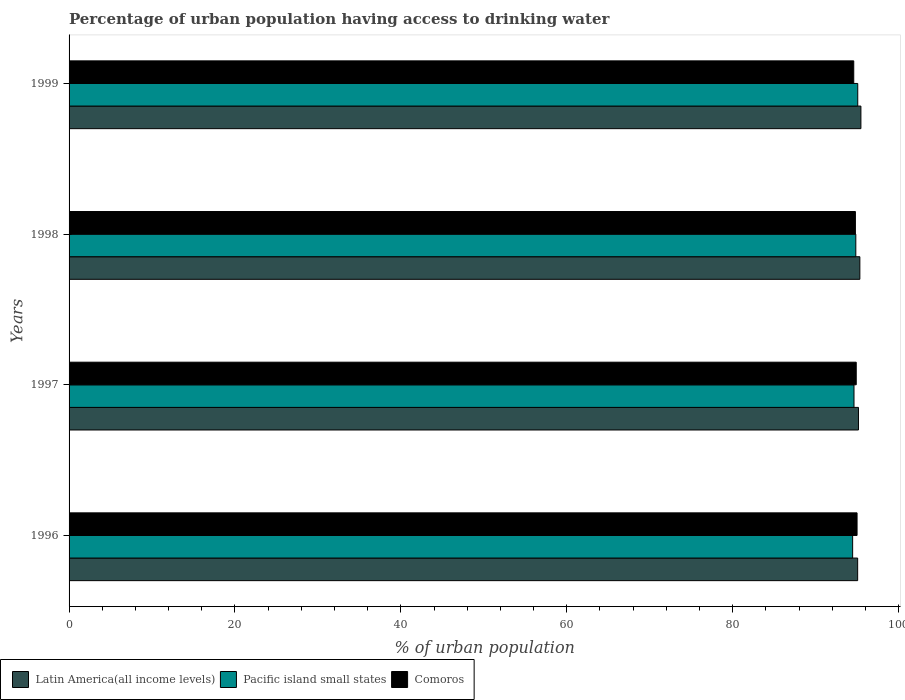Are the number of bars on each tick of the Y-axis equal?
Provide a succinct answer. Yes. How many bars are there on the 2nd tick from the top?
Offer a very short reply. 3. How many bars are there on the 2nd tick from the bottom?
Offer a terse response. 3. What is the percentage of urban population having access to drinking water in Pacific island small states in 1998?
Your answer should be very brief. 94.85. Across all years, what is the maximum percentage of urban population having access to drinking water in Comoros?
Your answer should be compact. 95. Across all years, what is the minimum percentage of urban population having access to drinking water in Comoros?
Your answer should be compact. 94.6. In which year was the percentage of urban population having access to drinking water in Comoros maximum?
Ensure brevity in your answer.  1996. In which year was the percentage of urban population having access to drinking water in Latin America(all income levels) minimum?
Give a very brief answer. 1996. What is the total percentage of urban population having access to drinking water in Latin America(all income levels) in the graph?
Your response must be concise. 381.04. What is the difference between the percentage of urban population having access to drinking water in Latin America(all income levels) in 1997 and that in 1998?
Provide a short and direct response. -0.17. What is the difference between the percentage of urban population having access to drinking water in Latin America(all income levels) in 1998 and the percentage of urban population having access to drinking water in Comoros in 1997?
Make the answer very short. 0.44. What is the average percentage of urban population having access to drinking water in Comoros per year?
Ensure brevity in your answer.  94.82. In the year 1996, what is the difference between the percentage of urban population having access to drinking water in Pacific island small states and percentage of urban population having access to drinking water in Comoros?
Provide a short and direct response. -0.53. What is the ratio of the percentage of urban population having access to drinking water in Pacific island small states in 1998 to that in 1999?
Offer a very short reply. 1. What is the difference between the highest and the second highest percentage of urban population having access to drinking water in Pacific island small states?
Offer a terse response. 0.23. What is the difference between the highest and the lowest percentage of urban population having access to drinking water in Pacific island small states?
Make the answer very short. 0.62. Is the sum of the percentage of urban population having access to drinking water in Latin America(all income levels) in 1996 and 1998 greater than the maximum percentage of urban population having access to drinking water in Pacific island small states across all years?
Ensure brevity in your answer.  Yes. What does the 3rd bar from the top in 1998 represents?
Your answer should be compact. Latin America(all income levels). What does the 2nd bar from the bottom in 1999 represents?
Keep it short and to the point. Pacific island small states. How many years are there in the graph?
Keep it short and to the point. 4. Does the graph contain grids?
Make the answer very short. No. How are the legend labels stacked?
Make the answer very short. Horizontal. What is the title of the graph?
Provide a succinct answer. Percentage of urban population having access to drinking water. Does "Maldives" appear as one of the legend labels in the graph?
Your answer should be very brief. No. What is the label or title of the X-axis?
Provide a succinct answer. % of urban population. What is the % of urban population in Latin America(all income levels) in 1996?
Offer a very short reply. 95.07. What is the % of urban population in Pacific island small states in 1996?
Your answer should be very brief. 94.47. What is the % of urban population of Comoros in 1996?
Your answer should be very brief. 95. What is the % of urban population in Latin America(all income levels) in 1997?
Your answer should be very brief. 95.17. What is the % of urban population of Pacific island small states in 1997?
Offer a terse response. 94.63. What is the % of urban population of Comoros in 1997?
Give a very brief answer. 94.9. What is the % of urban population of Latin America(all income levels) in 1998?
Offer a terse response. 95.34. What is the % of urban population in Pacific island small states in 1998?
Ensure brevity in your answer.  94.85. What is the % of urban population of Comoros in 1998?
Keep it short and to the point. 94.8. What is the % of urban population of Latin America(all income levels) in 1999?
Your answer should be compact. 95.46. What is the % of urban population in Pacific island small states in 1999?
Make the answer very short. 95.08. What is the % of urban population of Comoros in 1999?
Your answer should be very brief. 94.6. Across all years, what is the maximum % of urban population in Latin America(all income levels)?
Provide a short and direct response. 95.46. Across all years, what is the maximum % of urban population in Pacific island small states?
Your answer should be compact. 95.08. Across all years, what is the minimum % of urban population in Latin America(all income levels)?
Ensure brevity in your answer.  95.07. Across all years, what is the minimum % of urban population in Pacific island small states?
Give a very brief answer. 94.47. Across all years, what is the minimum % of urban population in Comoros?
Your response must be concise. 94.6. What is the total % of urban population in Latin America(all income levels) in the graph?
Your response must be concise. 381.04. What is the total % of urban population of Pacific island small states in the graph?
Your answer should be compact. 379.03. What is the total % of urban population of Comoros in the graph?
Make the answer very short. 379.3. What is the difference between the % of urban population in Latin America(all income levels) in 1996 and that in 1997?
Make the answer very short. -0.1. What is the difference between the % of urban population in Pacific island small states in 1996 and that in 1997?
Your answer should be compact. -0.16. What is the difference between the % of urban population of Comoros in 1996 and that in 1997?
Keep it short and to the point. 0.1. What is the difference between the % of urban population in Latin America(all income levels) in 1996 and that in 1998?
Your answer should be very brief. -0.27. What is the difference between the % of urban population of Pacific island small states in 1996 and that in 1998?
Your answer should be compact. -0.38. What is the difference between the % of urban population in Latin America(all income levels) in 1996 and that in 1999?
Ensure brevity in your answer.  -0.39. What is the difference between the % of urban population of Pacific island small states in 1996 and that in 1999?
Make the answer very short. -0.62. What is the difference between the % of urban population in Comoros in 1996 and that in 1999?
Make the answer very short. 0.4. What is the difference between the % of urban population of Latin America(all income levels) in 1997 and that in 1998?
Make the answer very short. -0.17. What is the difference between the % of urban population in Pacific island small states in 1997 and that in 1998?
Keep it short and to the point. -0.22. What is the difference between the % of urban population of Latin America(all income levels) in 1997 and that in 1999?
Make the answer very short. -0.29. What is the difference between the % of urban population of Pacific island small states in 1997 and that in 1999?
Provide a succinct answer. -0.45. What is the difference between the % of urban population in Latin America(all income levels) in 1998 and that in 1999?
Give a very brief answer. -0.13. What is the difference between the % of urban population of Pacific island small states in 1998 and that in 1999?
Keep it short and to the point. -0.23. What is the difference between the % of urban population of Comoros in 1998 and that in 1999?
Your response must be concise. 0.2. What is the difference between the % of urban population of Latin America(all income levels) in 1996 and the % of urban population of Pacific island small states in 1997?
Give a very brief answer. 0.44. What is the difference between the % of urban population in Latin America(all income levels) in 1996 and the % of urban population in Comoros in 1997?
Your response must be concise. 0.17. What is the difference between the % of urban population of Pacific island small states in 1996 and the % of urban population of Comoros in 1997?
Give a very brief answer. -0.43. What is the difference between the % of urban population in Latin America(all income levels) in 1996 and the % of urban population in Pacific island small states in 1998?
Provide a succinct answer. 0.22. What is the difference between the % of urban population in Latin America(all income levels) in 1996 and the % of urban population in Comoros in 1998?
Provide a succinct answer. 0.27. What is the difference between the % of urban population of Pacific island small states in 1996 and the % of urban population of Comoros in 1998?
Make the answer very short. -0.33. What is the difference between the % of urban population in Latin America(all income levels) in 1996 and the % of urban population in Pacific island small states in 1999?
Ensure brevity in your answer.  -0.01. What is the difference between the % of urban population in Latin America(all income levels) in 1996 and the % of urban population in Comoros in 1999?
Provide a succinct answer. 0.47. What is the difference between the % of urban population in Pacific island small states in 1996 and the % of urban population in Comoros in 1999?
Give a very brief answer. -0.13. What is the difference between the % of urban population of Latin America(all income levels) in 1997 and the % of urban population of Pacific island small states in 1998?
Give a very brief answer. 0.32. What is the difference between the % of urban population of Latin America(all income levels) in 1997 and the % of urban population of Comoros in 1998?
Offer a terse response. 0.37. What is the difference between the % of urban population of Pacific island small states in 1997 and the % of urban population of Comoros in 1998?
Give a very brief answer. -0.17. What is the difference between the % of urban population in Latin America(all income levels) in 1997 and the % of urban population in Pacific island small states in 1999?
Your answer should be compact. 0.09. What is the difference between the % of urban population in Latin America(all income levels) in 1997 and the % of urban population in Comoros in 1999?
Make the answer very short. 0.57. What is the difference between the % of urban population of Pacific island small states in 1997 and the % of urban population of Comoros in 1999?
Offer a terse response. 0.03. What is the difference between the % of urban population of Latin America(all income levels) in 1998 and the % of urban population of Pacific island small states in 1999?
Keep it short and to the point. 0.25. What is the difference between the % of urban population in Latin America(all income levels) in 1998 and the % of urban population in Comoros in 1999?
Keep it short and to the point. 0.74. What is the difference between the % of urban population in Pacific island small states in 1998 and the % of urban population in Comoros in 1999?
Your response must be concise. 0.25. What is the average % of urban population in Latin America(all income levels) per year?
Give a very brief answer. 95.26. What is the average % of urban population in Pacific island small states per year?
Ensure brevity in your answer.  94.76. What is the average % of urban population in Comoros per year?
Your answer should be very brief. 94.83. In the year 1996, what is the difference between the % of urban population of Latin America(all income levels) and % of urban population of Pacific island small states?
Provide a short and direct response. 0.6. In the year 1996, what is the difference between the % of urban population of Latin America(all income levels) and % of urban population of Comoros?
Keep it short and to the point. 0.07. In the year 1996, what is the difference between the % of urban population of Pacific island small states and % of urban population of Comoros?
Your response must be concise. -0.53. In the year 1997, what is the difference between the % of urban population in Latin America(all income levels) and % of urban population in Pacific island small states?
Provide a short and direct response. 0.54. In the year 1997, what is the difference between the % of urban population of Latin America(all income levels) and % of urban population of Comoros?
Your answer should be compact. 0.27. In the year 1997, what is the difference between the % of urban population of Pacific island small states and % of urban population of Comoros?
Ensure brevity in your answer.  -0.27. In the year 1998, what is the difference between the % of urban population in Latin America(all income levels) and % of urban population in Pacific island small states?
Make the answer very short. 0.49. In the year 1998, what is the difference between the % of urban population of Latin America(all income levels) and % of urban population of Comoros?
Your answer should be compact. 0.54. In the year 1998, what is the difference between the % of urban population in Pacific island small states and % of urban population in Comoros?
Your answer should be compact. 0.05. In the year 1999, what is the difference between the % of urban population in Latin America(all income levels) and % of urban population in Pacific island small states?
Your answer should be compact. 0.38. In the year 1999, what is the difference between the % of urban population in Latin America(all income levels) and % of urban population in Comoros?
Provide a short and direct response. 0.86. In the year 1999, what is the difference between the % of urban population of Pacific island small states and % of urban population of Comoros?
Your response must be concise. 0.48. What is the ratio of the % of urban population of Latin America(all income levels) in 1996 to that in 1997?
Provide a short and direct response. 1. What is the ratio of the % of urban population of Latin America(all income levels) in 1996 to that in 1998?
Your response must be concise. 1. What is the ratio of the % of urban population in Pacific island small states in 1996 to that in 1998?
Offer a very short reply. 1. What is the ratio of the % of urban population of Comoros in 1996 to that in 1998?
Ensure brevity in your answer.  1. What is the ratio of the % of urban population in Pacific island small states in 1996 to that in 1999?
Your answer should be very brief. 0.99. What is the ratio of the % of urban population in Pacific island small states in 1997 to that in 1999?
Ensure brevity in your answer.  1. What is the ratio of the % of urban population of Comoros in 1997 to that in 1999?
Provide a succinct answer. 1. What is the ratio of the % of urban population in Pacific island small states in 1998 to that in 1999?
Keep it short and to the point. 1. What is the ratio of the % of urban population of Comoros in 1998 to that in 1999?
Your answer should be compact. 1. What is the difference between the highest and the second highest % of urban population in Latin America(all income levels)?
Keep it short and to the point. 0.13. What is the difference between the highest and the second highest % of urban population in Pacific island small states?
Give a very brief answer. 0.23. What is the difference between the highest and the second highest % of urban population of Comoros?
Offer a terse response. 0.1. What is the difference between the highest and the lowest % of urban population in Latin America(all income levels)?
Offer a terse response. 0.39. What is the difference between the highest and the lowest % of urban population in Pacific island small states?
Provide a succinct answer. 0.62. 